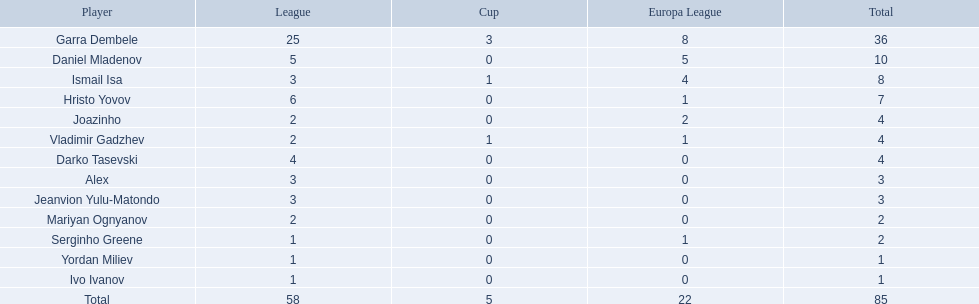Which players were unable to score in each of the three competitions? Daniel Mladenov, Hristo Yovov, Joazinho, Darko Tasevski, Alex, Jeanvion Yulu-Matondo, Mariyan Ognyanov, Serginho Greene, Yordan Miliev, Ivo Ivanov. From those, who had 5 or fewer total points? Darko Tasevski, Alex, Jeanvion Yulu-Matondo, Mariyan Ognyanov, Serginho Greene, Yordan Miliev, Ivo Ivanov. Who among them scored more than 1 overall? Darko Tasevski, Alex, Jeanvion Yulu-Matondo, Mariyan Ognyanov. Which player had the lowest number of league points? Mariyan Ognyanov. 